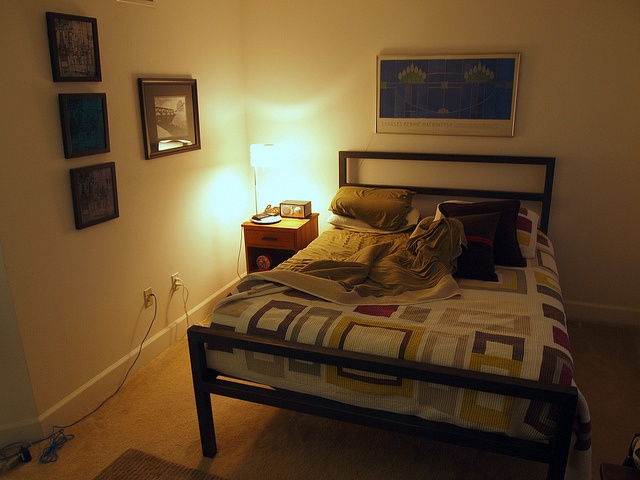Describe the objects in this image and their specific colors. I can see a bed in maroon, black, and olive tones in this image. 